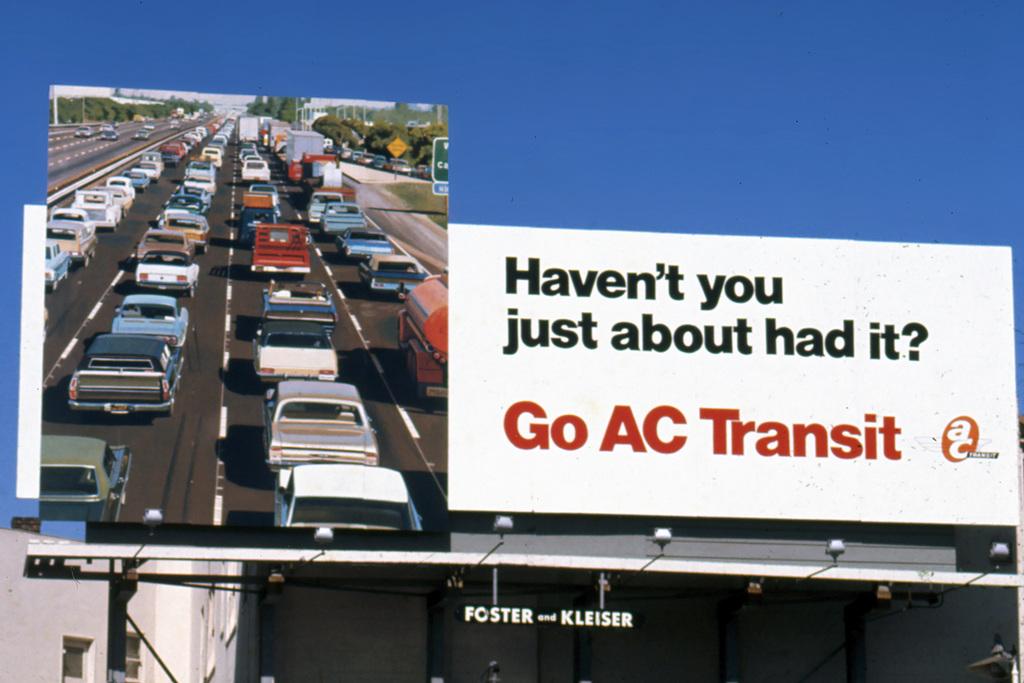What do you think they have had enough off?
Ensure brevity in your answer.  Traffic. What is the company on the billboard?
Provide a short and direct response. Ac transit. 